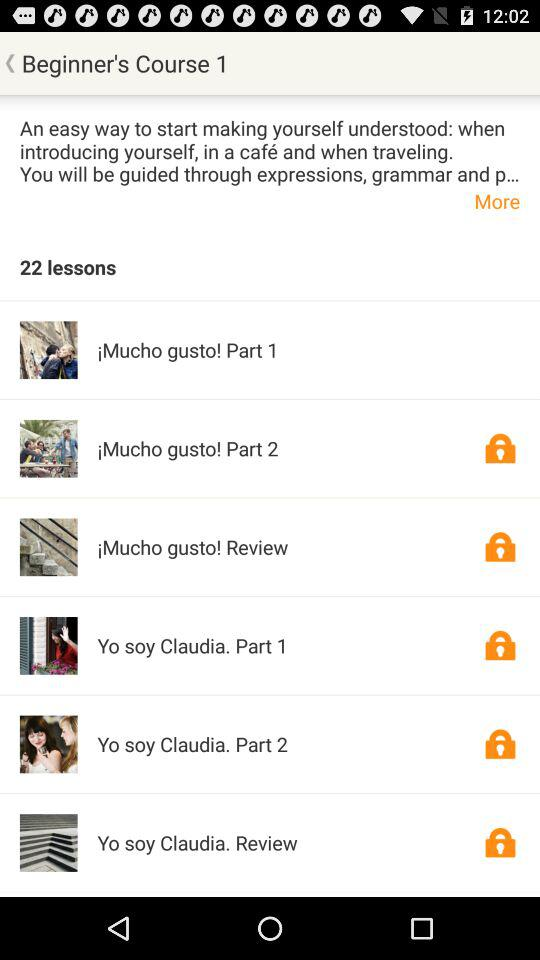How many lessons are there in this course?
Answer the question using a single word or phrase. 22 